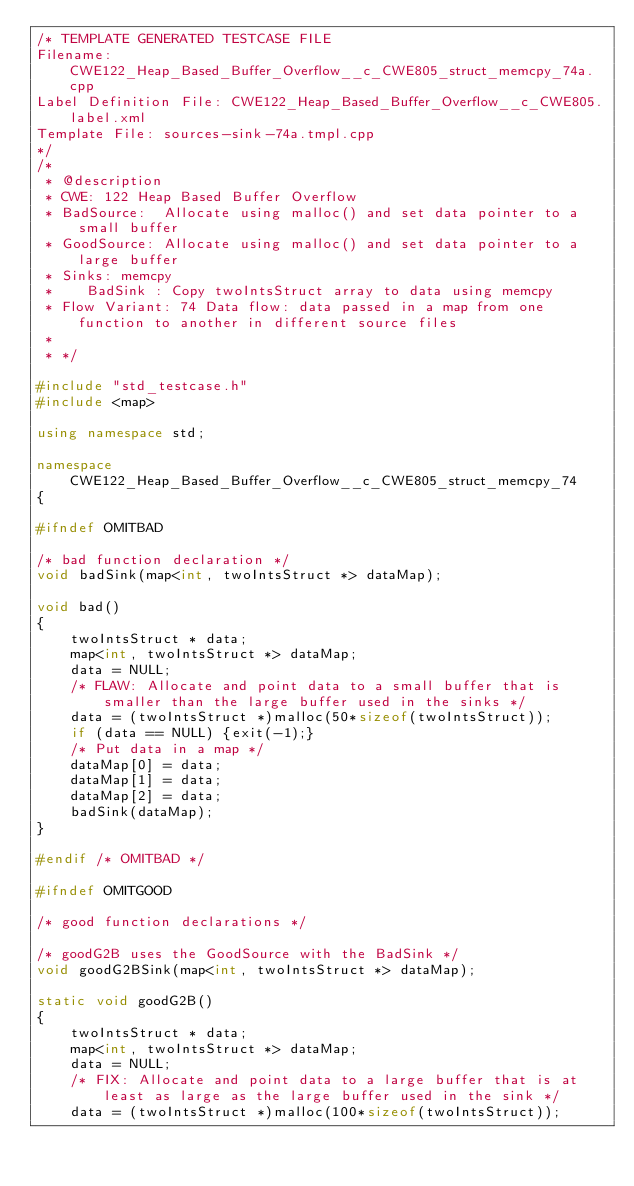Convert code to text. <code><loc_0><loc_0><loc_500><loc_500><_C++_>/* TEMPLATE GENERATED TESTCASE FILE
Filename: CWE122_Heap_Based_Buffer_Overflow__c_CWE805_struct_memcpy_74a.cpp
Label Definition File: CWE122_Heap_Based_Buffer_Overflow__c_CWE805.label.xml
Template File: sources-sink-74a.tmpl.cpp
*/
/*
 * @description
 * CWE: 122 Heap Based Buffer Overflow
 * BadSource:  Allocate using malloc() and set data pointer to a small buffer
 * GoodSource: Allocate using malloc() and set data pointer to a large buffer
 * Sinks: memcpy
 *    BadSink : Copy twoIntsStruct array to data using memcpy
 * Flow Variant: 74 Data flow: data passed in a map from one function to another in different source files
 *
 * */

#include "std_testcase.h"
#include <map>

using namespace std;

namespace CWE122_Heap_Based_Buffer_Overflow__c_CWE805_struct_memcpy_74
{

#ifndef OMITBAD

/* bad function declaration */
void badSink(map<int, twoIntsStruct *> dataMap);

void bad()
{
    twoIntsStruct * data;
    map<int, twoIntsStruct *> dataMap;
    data = NULL;
    /* FLAW: Allocate and point data to a small buffer that is smaller than the large buffer used in the sinks */
    data = (twoIntsStruct *)malloc(50*sizeof(twoIntsStruct));
    if (data == NULL) {exit(-1);}
    /* Put data in a map */
    dataMap[0] = data;
    dataMap[1] = data;
    dataMap[2] = data;
    badSink(dataMap);
}

#endif /* OMITBAD */

#ifndef OMITGOOD

/* good function declarations */

/* goodG2B uses the GoodSource with the BadSink */
void goodG2BSink(map<int, twoIntsStruct *> dataMap);

static void goodG2B()
{
    twoIntsStruct * data;
    map<int, twoIntsStruct *> dataMap;
    data = NULL;
    /* FIX: Allocate and point data to a large buffer that is at least as large as the large buffer used in the sink */
    data = (twoIntsStruct *)malloc(100*sizeof(twoIntsStruct));</code> 